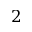Convert formula to latex. <formula><loc_0><loc_0><loc_500><loc_500>2</formula> 